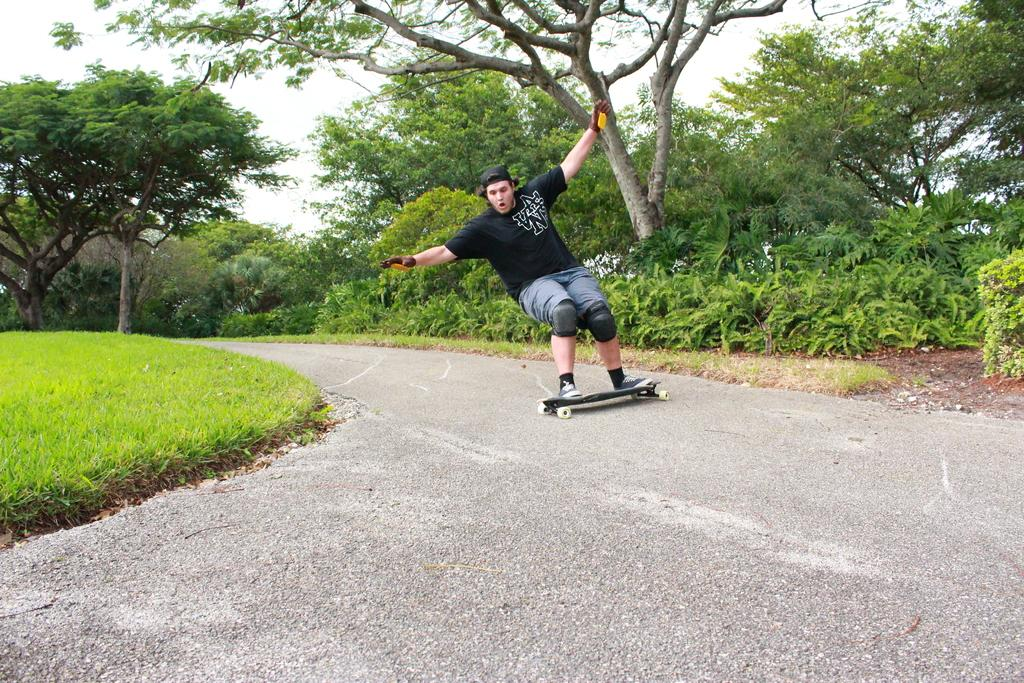What is the person in the image doing? There is a person skating in the image. On what surface is the person skating? The person is skating on a road. What can be seen on either side of the road? There are plants and trees on either side of the road. What time of day is it, based on the presence of a straw in the image? There is no straw present in the image, so it cannot be used to determine the time of day. 